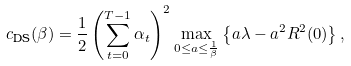<formula> <loc_0><loc_0><loc_500><loc_500>c _ { \text {DS} } ( \beta ) = \frac { 1 } { 2 } \left ( \sum _ { t = 0 } ^ { T - 1 } \alpha _ { t } \right ) ^ { 2 } \max _ { 0 \leq a \leq \frac { 1 } { \beta } } \left \{ a \lambda - a ^ { 2 } R ^ { 2 } ( 0 ) \right \} ,</formula> 